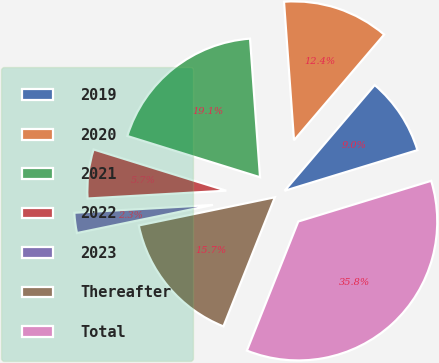<chart> <loc_0><loc_0><loc_500><loc_500><pie_chart><fcel>2019<fcel>2020<fcel>2021<fcel>2022<fcel>2023<fcel>Thereafter<fcel>Total<nl><fcel>9.04%<fcel>12.38%<fcel>19.06%<fcel>5.69%<fcel>2.35%<fcel>15.72%<fcel>35.76%<nl></chart> 